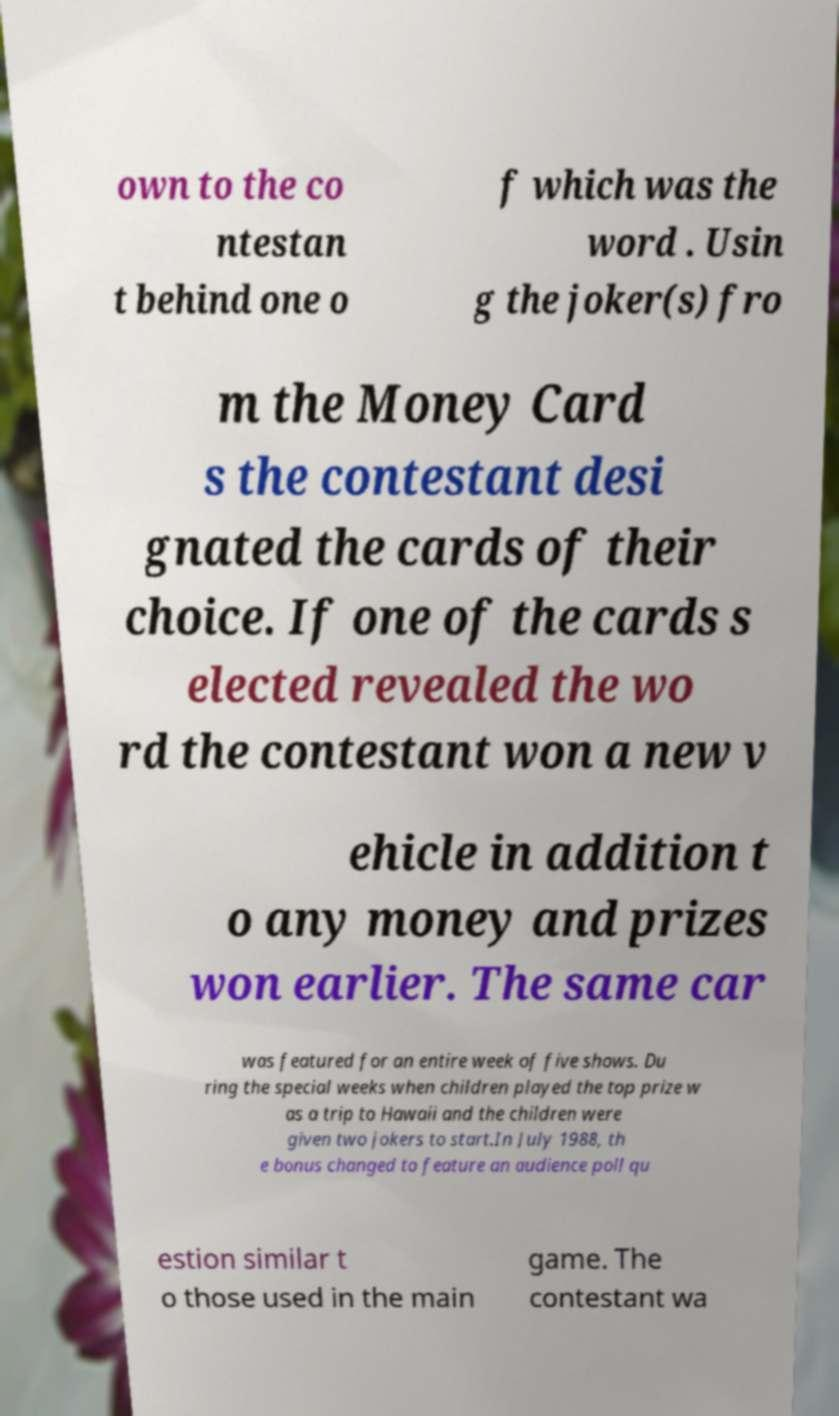For documentation purposes, I need the text within this image transcribed. Could you provide that? own to the co ntestan t behind one o f which was the word . Usin g the joker(s) fro m the Money Card s the contestant desi gnated the cards of their choice. If one of the cards s elected revealed the wo rd the contestant won a new v ehicle in addition t o any money and prizes won earlier. The same car was featured for an entire week of five shows. Du ring the special weeks when children played the top prize w as a trip to Hawaii and the children were given two jokers to start.In July 1988, th e bonus changed to feature an audience poll qu estion similar t o those used in the main game. The contestant wa 